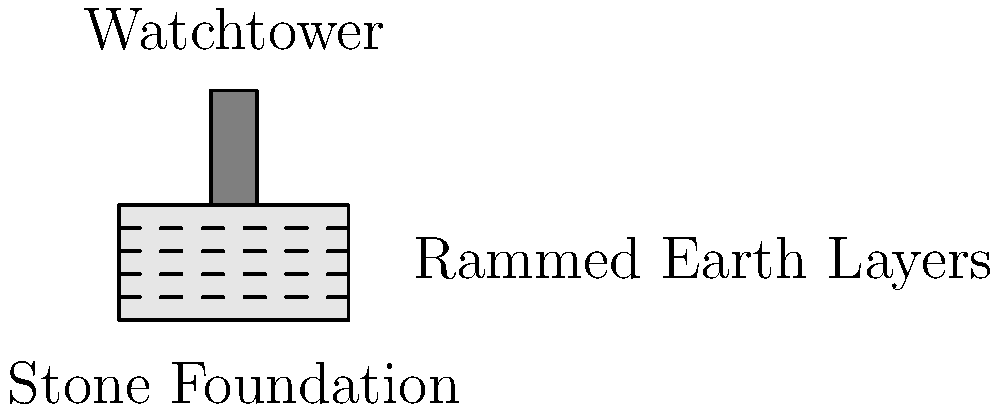Based on the architectural drawing of a section of the Great Wall of China, what construction technique is evident in the main body of the wall, and how might this technique have contributed to the wall's longevity? To answer this question, we need to analyze the architectural drawing and identify key features:

1. The main body of the wall is shown with horizontal dashed lines, indicating distinct layers.
2. These layers represent the rammed earth technique used in constructing the Great Wall.
3. Rammed earth construction involves:
   a. Compacting moistened soil into layers
   b. Using wooden frames to shape each layer
   c. Adding successive layers to build up the wall's height

4. The rammed earth technique contributed to the wall's longevity through:
   a. Increased density and strength of the wall material
   b. Better resistance to weathering and erosion
   c. Improved structural integrity due to the layered construction

5. The drawing also shows:
   a. A stone foundation, providing a stable base for the wall
   b. A watchtower, indicating defensive capabilities

It's important to note that while this drawing provides valuable insights into the construction techniques, relying solely on such representations without corroborating archaeological evidence could lead to incomplete or erroneous interpretations of historical construction methods.
Answer: Rammed earth technique, contributing to strength and durability through compacted layered construction. 